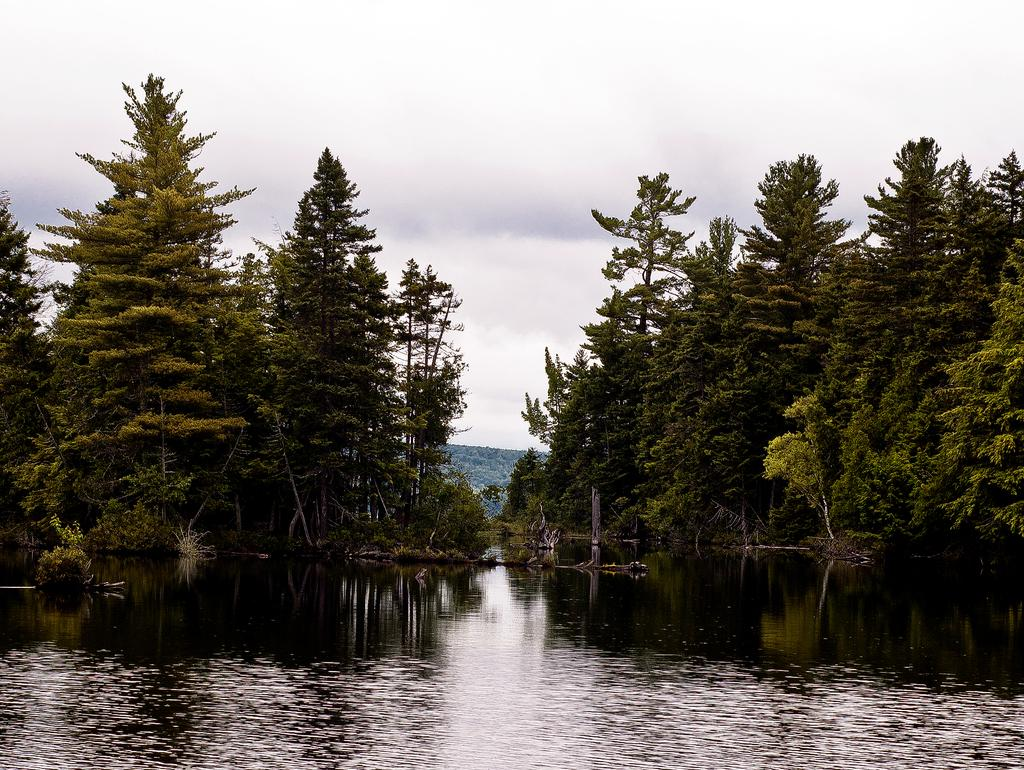What is located in the center of the image? There are trees in the center of the image. What type of geographical feature can be seen in the image? There are hills in the image. What is visible at the bottom of the image? Water is visible at the bottom of the image. What is present in the sky at the top of the image? Clouds are present in the sky at the top of the image. What type of roof can be seen on the trees in the image? There are no roofs present on the trees in the image, as trees do not have roofs. What color is the glass on the hills in the image? There is no glass present on the hills in the image. 